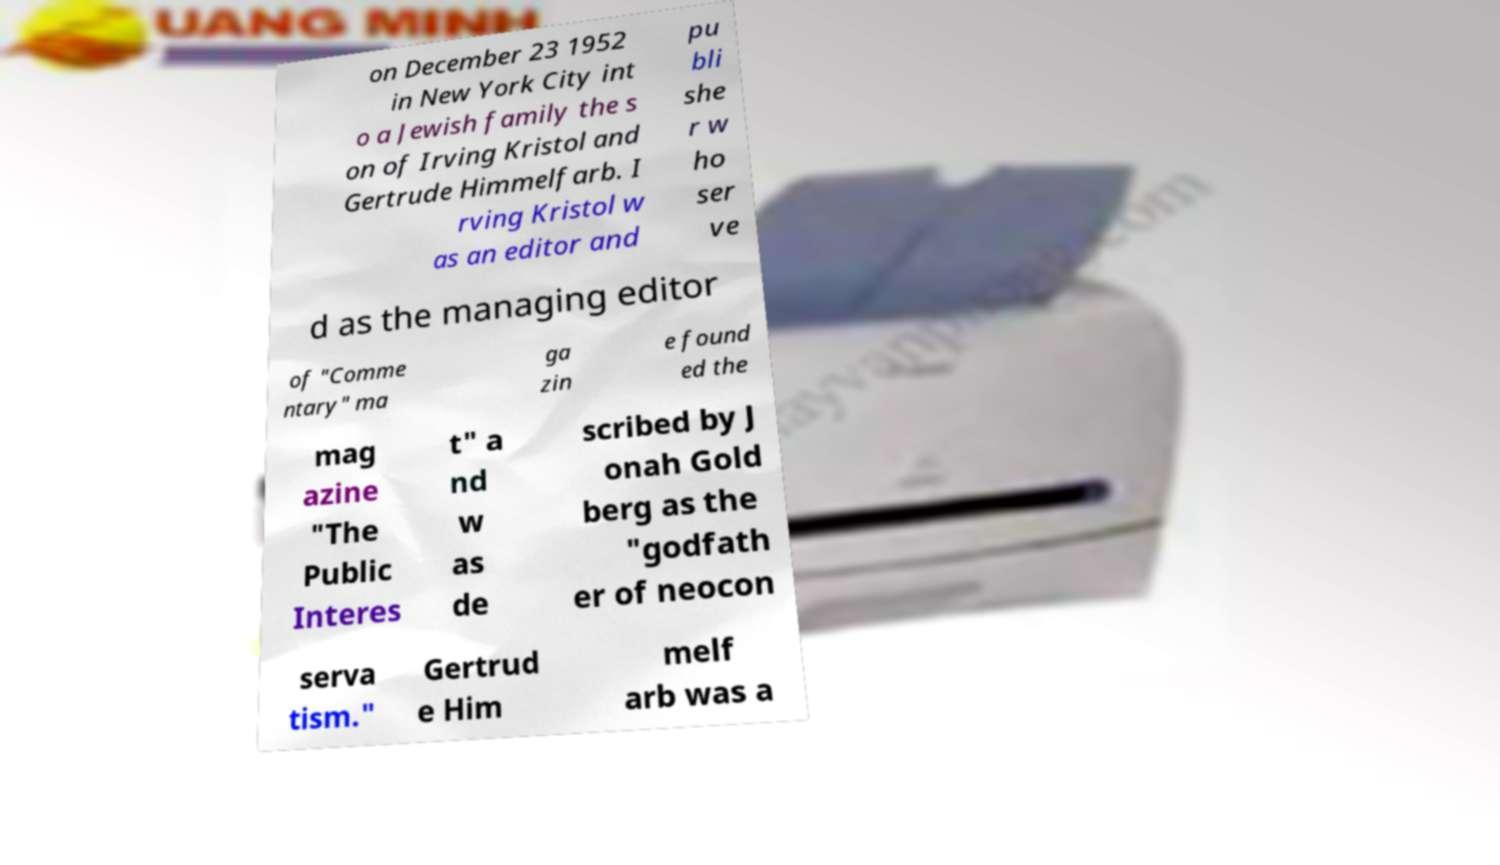Please identify and transcribe the text found in this image. on December 23 1952 in New York City int o a Jewish family the s on of Irving Kristol and Gertrude Himmelfarb. I rving Kristol w as an editor and pu bli she r w ho ser ve d as the managing editor of "Comme ntary" ma ga zin e found ed the mag azine "The Public Interes t" a nd w as de scribed by J onah Gold berg as the "godfath er of neocon serva tism." Gertrud e Him melf arb was a 